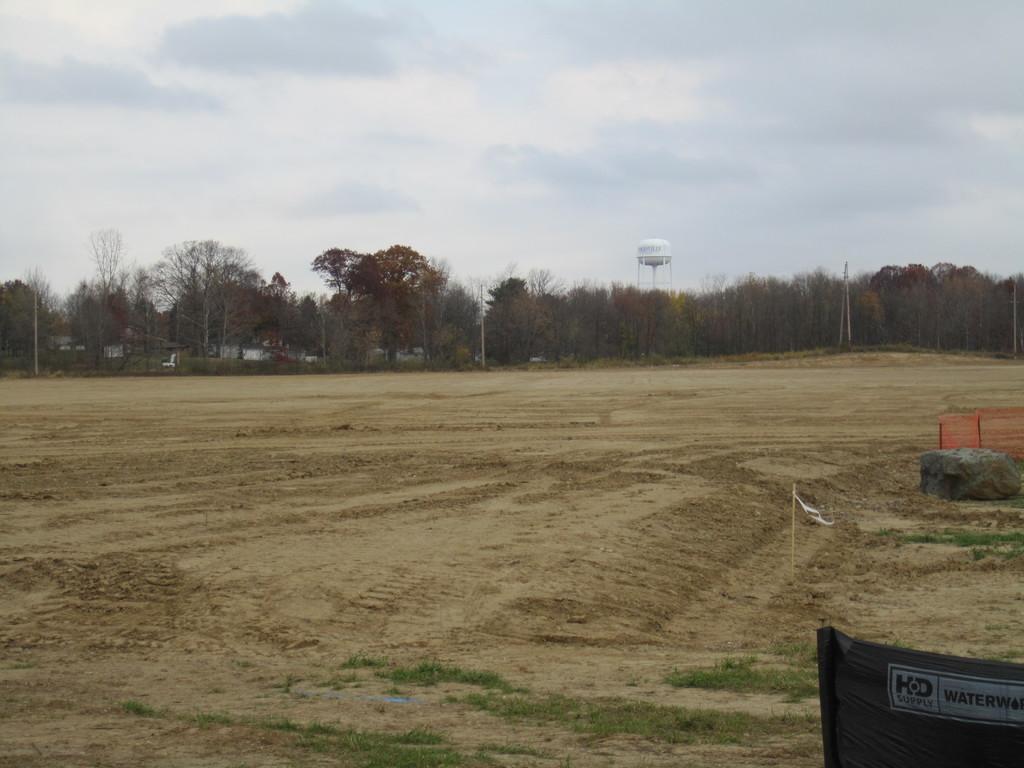Could you give a brief overview of what you see in this image? At the bottom of the image there is ground. In the bottom right corner of the image there is a poster with something written on it. And also there is a rock. In the background there are trees and poles. And also there is a tanker. At the top of the image there is sky with clouds. 